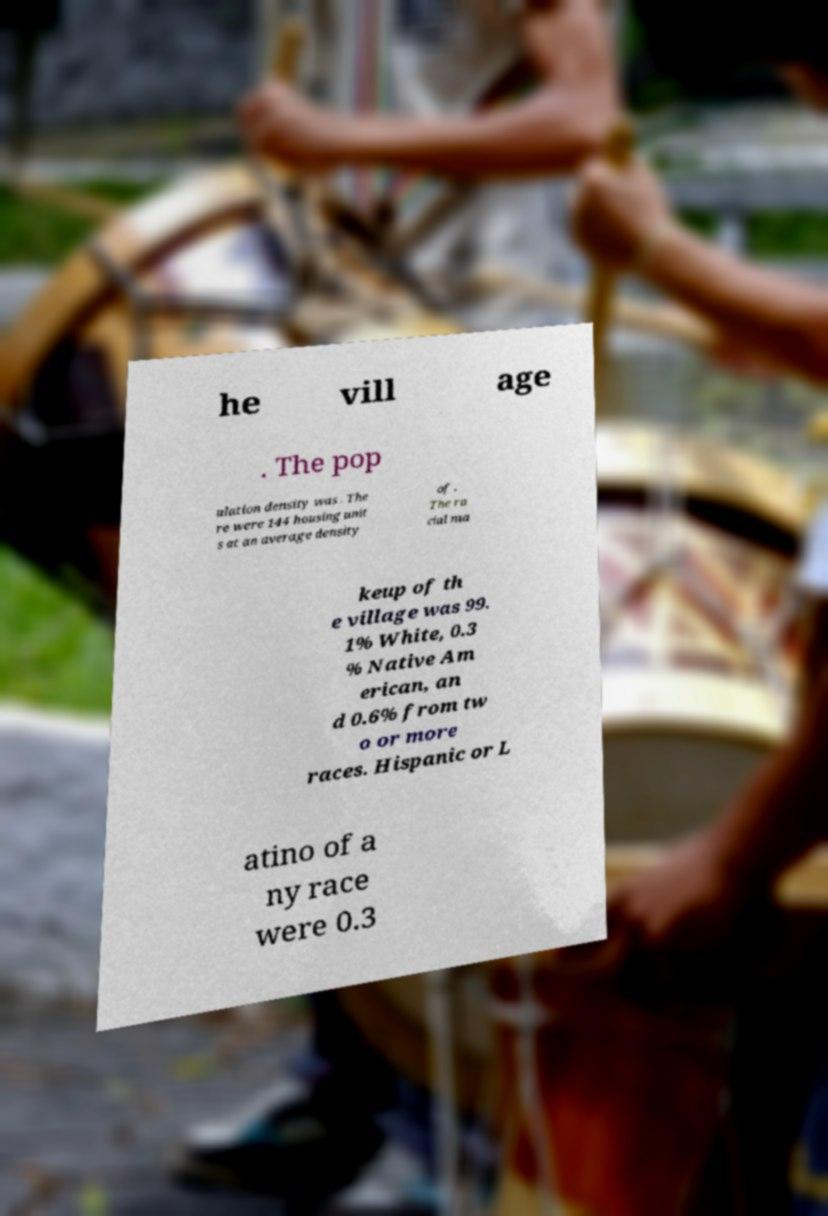Can you read and provide the text displayed in the image?This photo seems to have some interesting text. Can you extract and type it out for me? he vill age . The pop ulation density was . The re were 144 housing unit s at an average density of . The ra cial ma keup of th e village was 99. 1% White, 0.3 % Native Am erican, an d 0.6% from tw o or more races. Hispanic or L atino of a ny race were 0.3 